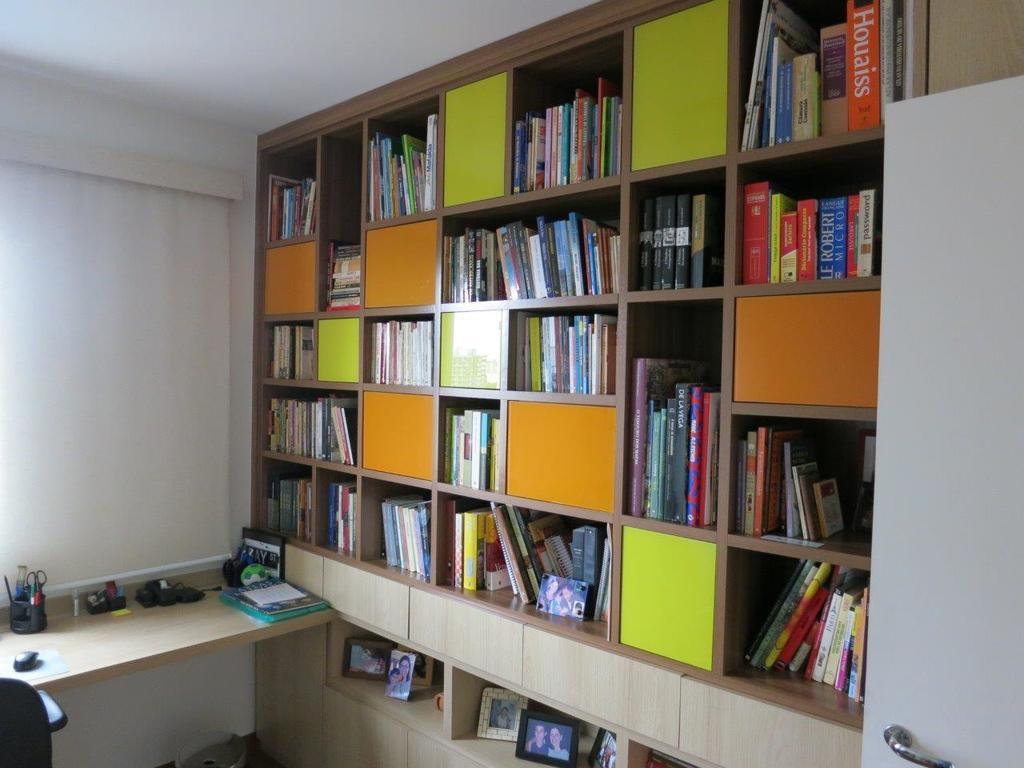<image>
Relay a brief, clear account of the picture shown. A large, built in bookshelf with various size sections contains photographs and books, including the titles "Password", "De La Viga", and "Houaiss". 